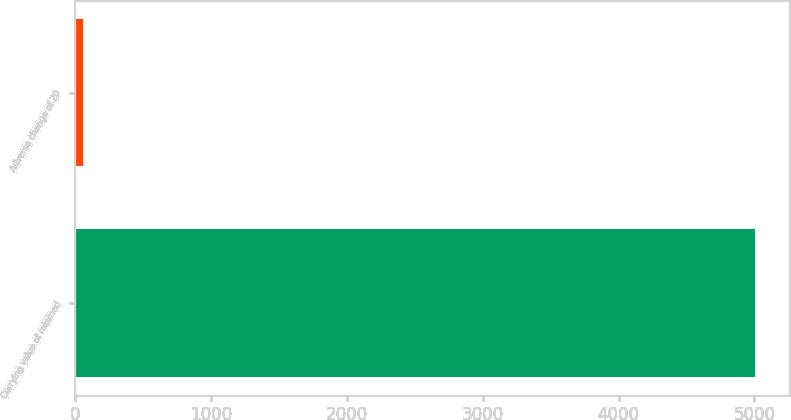Convert chart. <chart><loc_0><loc_0><loc_500><loc_500><bar_chart><fcel>Carrying value of retained<fcel>Adverse change of 20<nl><fcel>5006<fcel>57<nl></chart> 